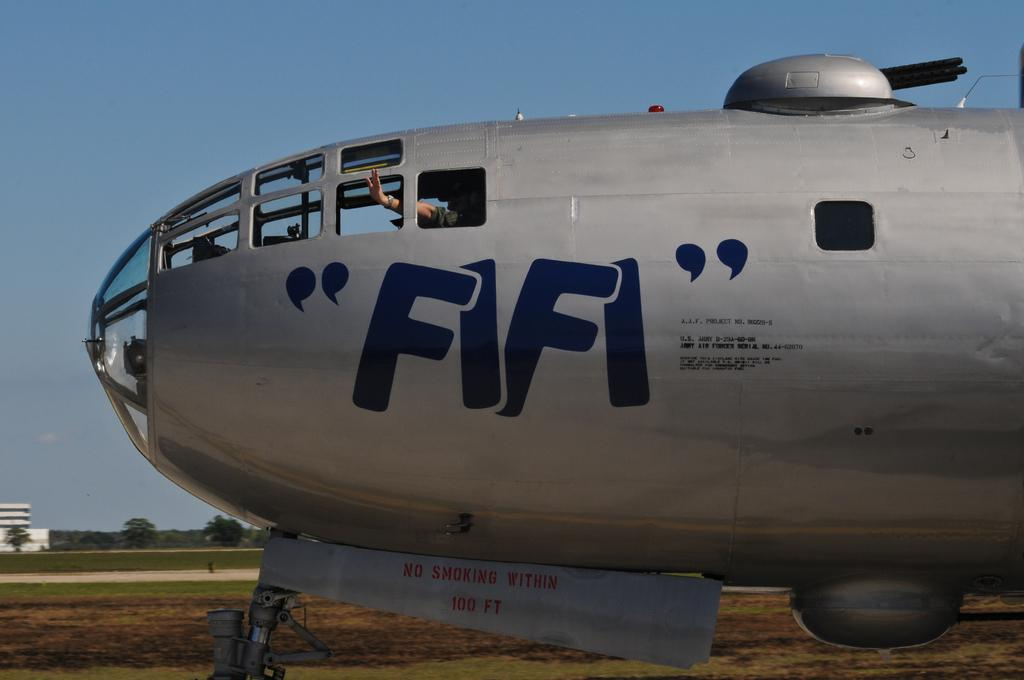What is the main subject of the picture? The main subject of the picture is an airplane. What is the color of the airplane? The airplane is grey in color. What can be seen on the airplane? There is blue text on the airplane. What can be seen in the background of the picture? There are trees, at least one building, and the sky visible in the background of the picture. What type of key is being used to unlock the car in the image? There is no car or key present in the image; it features an airplane with blue text and a background with trees, a building, and the sky. What is the surprise element in the image? There is no surprise element in the image; it is a straightforward depiction of an airplane with blue text and a background with trees, a building, and the sky. 